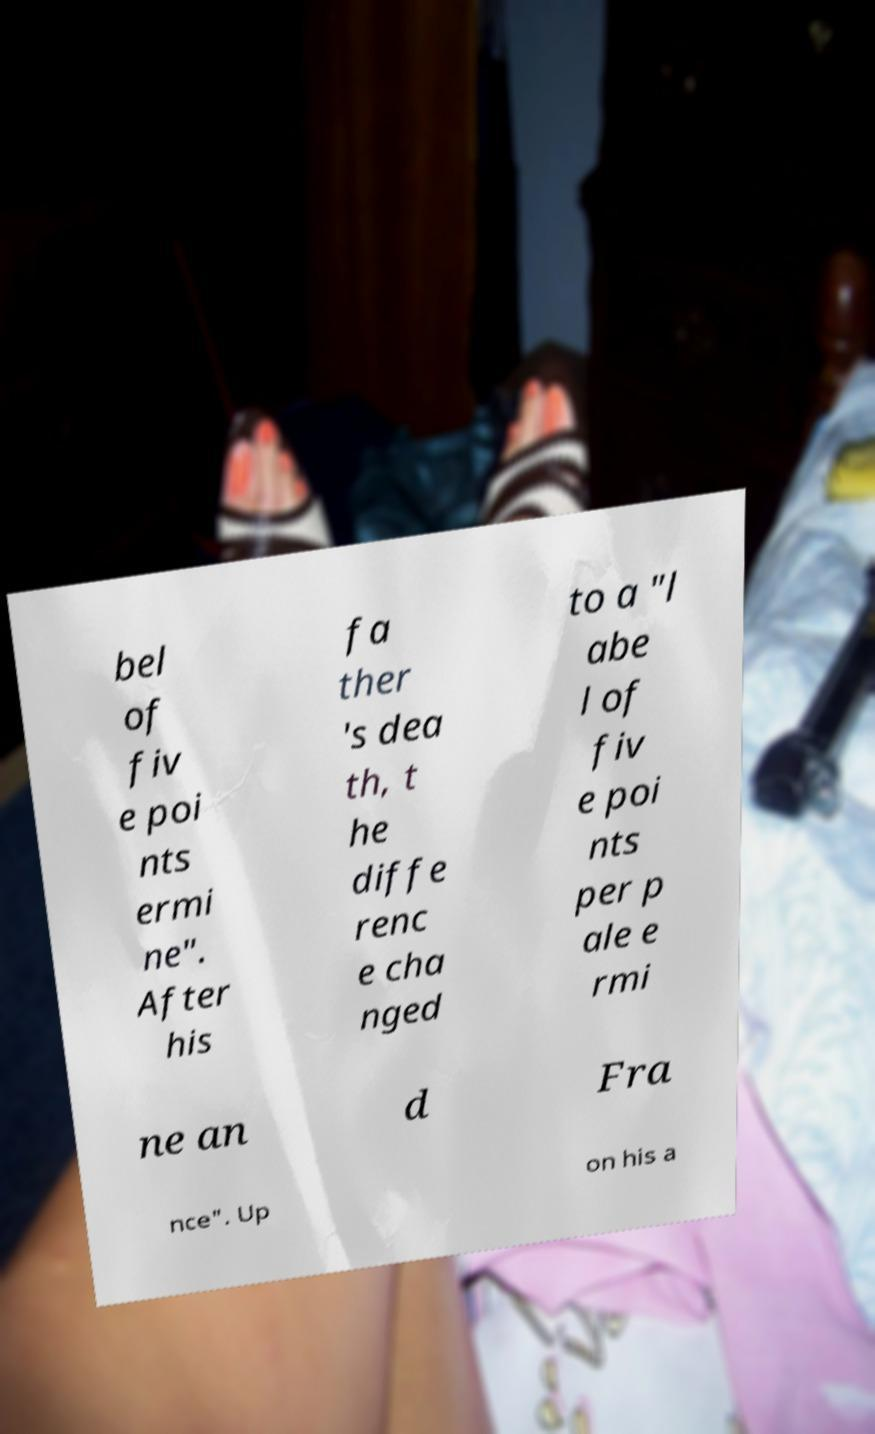What messages or text are displayed in this image? I need them in a readable, typed format. bel of fiv e poi nts ermi ne". After his fa ther 's dea th, t he diffe renc e cha nged to a "l abe l of fiv e poi nts per p ale e rmi ne an d Fra nce". Up on his a 